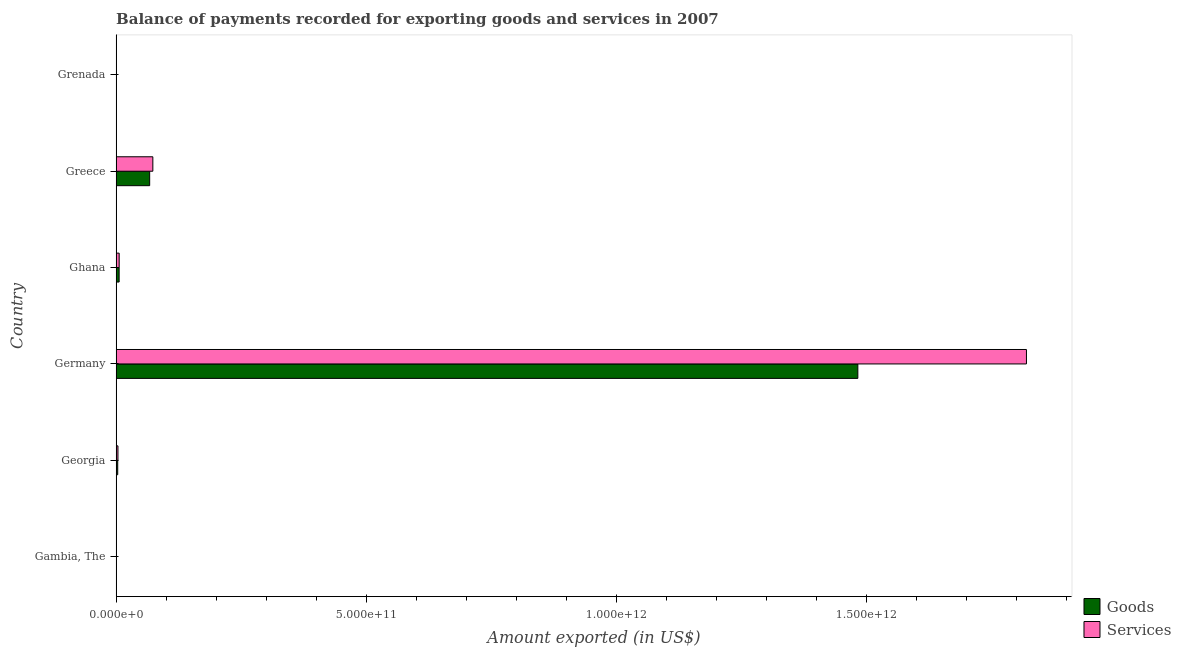How many different coloured bars are there?
Offer a terse response. 2. Are the number of bars per tick equal to the number of legend labels?
Your answer should be compact. Yes. Are the number of bars on each tick of the Y-axis equal?
Offer a very short reply. Yes. What is the label of the 1st group of bars from the top?
Offer a terse response. Grenada. What is the amount of services exported in Georgia?
Your answer should be compact. 3.65e+09. Across all countries, what is the maximum amount of goods exported?
Offer a terse response. 1.48e+12. Across all countries, what is the minimum amount of services exported?
Provide a short and direct response. 2.23e+08. In which country was the amount of goods exported maximum?
Provide a short and direct response. Germany. In which country was the amount of goods exported minimum?
Give a very brief answer. Grenada. What is the total amount of services exported in the graph?
Offer a terse response. 1.90e+12. What is the difference between the amount of goods exported in Gambia, The and that in Ghana?
Offer a very short reply. -5.74e+09. What is the difference between the amount of goods exported in Gambia, The and the amount of services exported in Greece?
Provide a succinct answer. -7.31e+1. What is the average amount of services exported per country?
Offer a terse response. 3.17e+11. What is the difference between the amount of services exported and amount of goods exported in Grenada?
Your answer should be very brief. 1.37e+07. In how many countries, is the amount of goods exported greater than 1100000000000 US$?
Offer a very short reply. 1. What is the ratio of the amount of goods exported in Georgia to that in Greece?
Provide a succinct answer. 0.05. Is the amount of services exported in Gambia, The less than that in Germany?
Your answer should be very brief. Yes. Is the difference between the amount of goods exported in Georgia and Grenada greater than the difference between the amount of services exported in Georgia and Grenada?
Provide a short and direct response. No. What is the difference between the highest and the second highest amount of goods exported?
Make the answer very short. 1.42e+12. What is the difference between the highest and the lowest amount of services exported?
Give a very brief answer. 1.82e+12. What does the 1st bar from the top in Georgia represents?
Your answer should be compact. Services. What does the 1st bar from the bottom in Grenada represents?
Your answer should be very brief. Goods. How many bars are there?
Offer a terse response. 12. How many countries are there in the graph?
Your response must be concise. 6. What is the difference between two consecutive major ticks on the X-axis?
Your answer should be very brief. 5.00e+11. Does the graph contain grids?
Ensure brevity in your answer.  No. Where does the legend appear in the graph?
Your response must be concise. Bottom right. How many legend labels are there?
Your response must be concise. 2. What is the title of the graph?
Your answer should be compact. Balance of payments recorded for exporting goods and services in 2007. What is the label or title of the X-axis?
Your response must be concise. Amount exported (in US$). What is the Amount exported (in US$) in Goods in Gambia, The?
Ensure brevity in your answer.  2.62e+08. What is the Amount exported (in US$) in Services in Gambia, The?
Make the answer very short. 2.71e+08. What is the Amount exported (in US$) in Goods in Georgia?
Ensure brevity in your answer.  3.16e+09. What is the Amount exported (in US$) in Services in Georgia?
Offer a very short reply. 3.65e+09. What is the Amount exported (in US$) of Goods in Germany?
Offer a very short reply. 1.48e+12. What is the Amount exported (in US$) of Services in Germany?
Give a very brief answer. 1.82e+12. What is the Amount exported (in US$) in Goods in Ghana?
Provide a succinct answer. 6.00e+09. What is the Amount exported (in US$) of Services in Ghana?
Your answer should be compact. 6.09e+09. What is the Amount exported (in US$) in Goods in Greece?
Keep it short and to the point. 6.70e+1. What is the Amount exported (in US$) of Services in Greece?
Your answer should be very brief. 7.34e+1. What is the Amount exported (in US$) in Goods in Grenada?
Offer a terse response. 2.10e+08. What is the Amount exported (in US$) in Services in Grenada?
Your answer should be compact. 2.23e+08. Across all countries, what is the maximum Amount exported (in US$) in Goods?
Provide a short and direct response. 1.48e+12. Across all countries, what is the maximum Amount exported (in US$) of Services?
Offer a very short reply. 1.82e+12. Across all countries, what is the minimum Amount exported (in US$) in Goods?
Keep it short and to the point. 2.10e+08. Across all countries, what is the minimum Amount exported (in US$) of Services?
Make the answer very short. 2.23e+08. What is the total Amount exported (in US$) of Goods in the graph?
Your answer should be very brief. 1.56e+12. What is the total Amount exported (in US$) in Services in the graph?
Ensure brevity in your answer.  1.90e+12. What is the difference between the Amount exported (in US$) of Goods in Gambia, The and that in Georgia?
Your answer should be compact. -2.90e+09. What is the difference between the Amount exported (in US$) in Services in Gambia, The and that in Georgia?
Your answer should be very brief. -3.37e+09. What is the difference between the Amount exported (in US$) of Goods in Gambia, The and that in Germany?
Ensure brevity in your answer.  -1.48e+12. What is the difference between the Amount exported (in US$) of Services in Gambia, The and that in Germany?
Provide a short and direct response. -1.82e+12. What is the difference between the Amount exported (in US$) of Goods in Gambia, The and that in Ghana?
Provide a short and direct response. -5.74e+09. What is the difference between the Amount exported (in US$) in Services in Gambia, The and that in Ghana?
Keep it short and to the point. -5.82e+09. What is the difference between the Amount exported (in US$) of Goods in Gambia, The and that in Greece?
Give a very brief answer. -6.68e+1. What is the difference between the Amount exported (in US$) of Services in Gambia, The and that in Greece?
Keep it short and to the point. -7.31e+1. What is the difference between the Amount exported (in US$) of Goods in Gambia, The and that in Grenada?
Provide a short and direct response. 5.27e+07. What is the difference between the Amount exported (in US$) in Services in Gambia, The and that in Grenada?
Keep it short and to the point. 4.81e+07. What is the difference between the Amount exported (in US$) of Goods in Georgia and that in Germany?
Your answer should be very brief. -1.48e+12. What is the difference between the Amount exported (in US$) in Services in Georgia and that in Germany?
Your answer should be compact. -1.82e+12. What is the difference between the Amount exported (in US$) of Goods in Georgia and that in Ghana?
Make the answer very short. -2.84e+09. What is the difference between the Amount exported (in US$) of Services in Georgia and that in Ghana?
Offer a terse response. -2.44e+09. What is the difference between the Amount exported (in US$) in Goods in Georgia and that in Greece?
Make the answer very short. -6.39e+1. What is the difference between the Amount exported (in US$) in Services in Georgia and that in Greece?
Ensure brevity in your answer.  -6.97e+1. What is the difference between the Amount exported (in US$) in Goods in Georgia and that in Grenada?
Provide a short and direct response. 2.95e+09. What is the difference between the Amount exported (in US$) of Services in Georgia and that in Grenada?
Provide a short and direct response. 3.42e+09. What is the difference between the Amount exported (in US$) in Goods in Germany and that in Ghana?
Offer a terse response. 1.48e+12. What is the difference between the Amount exported (in US$) of Services in Germany and that in Ghana?
Keep it short and to the point. 1.81e+12. What is the difference between the Amount exported (in US$) of Goods in Germany and that in Greece?
Keep it short and to the point. 1.42e+12. What is the difference between the Amount exported (in US$) in Services in Germany and that in Greece?
Ensure brevity in your answer.  1.75e+12. What is the difference between the Amount exported (in US$) in Goods in Germany and that in Grenada?
Offer a very short reply. 1.48e+12. What is the difference between the Amount exported (in US$) of Services in Germany and that in Grenada?
Provide a short and direct response. 1.82e+12. What is the difference between the Amount exported (in US$) in Goods in Ghana and that in Greece?
Your response must be concise. -6.10e+1. What is the difference between the Amount exported (in US$) of Services in Ghana and that in Greece?
Your answer should be compact. -6.73e+1. What is the difference between the Amount exported (in US$) of Goods in Ghana and that in Grenada?
Your answer should be very brief. 5.79e+09. What is the difference between the Amount exported (in US$) of Services in Ghana and that in Grenada?
Your response must be concise. 5.86e+09. What is the difference between the Amount exported (in US$) of Goods in Greece and that in Grenada?
Offer a terse response. 6.68e+1. What is the difference between the Amount exported (in US$) of Services in Greece and that in Grenada?
Provide a short and direct response. 7.32e+1. What is the difference between the Amount exported (in US$) in Goods in Gambia, The and the Amount exported (in US$) in Services in Georgia?
Ensure brevity in your answer.  -3.38e+09. What is the difference between the Amount exported (in US$) of Goods in Gambia, The and the Amount exported (in US$) of Services in Germany?
Ensure brevity in your answer.  -1.82e+12. What is the difference between the Amount exported (in US$) of Goods in Gambia, The and the Amount exported (in US$) of Services in Ghana?
Your answer should be compact. -5.83e+09. What is the difference between the Amount exported (in US$) of Goods in Gambia, The and the Amount exported (in US$) of Services in Greece?
Ensure brevity in your answer.  -7.31e+1. What is the difference between the Amount exported (in US$) of Goods in Gambia, The and the Amount exported (in US$) of Services in Grenada?
Keep it short and to the point. 3.91e+07. What is the difference between the Amount exported (in US$) of Goods in Georgia and the Amount exported (in US$) of Services in Germany?
Your answer should be compact. -1.82e+12. What is the difference between the Amount exported (in US$) of Goods in Georgia and the Amount exported (in US$) of Services in Ghana?
Ensure brevity in your answer.  -2.93e+09. What is the difference between the Amount exported (in US$) of Goods in Georgia and the Amount exported (in US$) of Services in Greece?
Keep it short and to the point. -7.02e+1. What is the difference between the Amount exported (in US$) in Goods in Georgia and the Amount exported (in US$) in Services in Grenada?
Your response must be concise. 2.94e+09. What is the difference between the Amount exported (in US$) of Goods in Germany and the Amount exported (in US$) of Services in Ghana?
Ensure brevity in your answer.  1.48e+12. What is the difference between the Amount exported (in US$) in Goods in Germany and the Amount exported (in US$) in Services in Greece?
Your answer should be very brief. 1.41e+12. What is the difference between the Amount exported (in US$) of Goods in Germany and the Amount exported (in US$) of Services in Grenada?
Keep it short and to the point. 1.48e+12. What is the difference between the Amount exported (in US$) of Goods in Ghana and the Amount exported (in US$) of Services in Greece?
Provide a succinct answer. -6.74e+1. What is the difference between the Amount exported (in US$) in Goods in Ghana and the Amount exported (in US$) in Services in Grenada?
Ensure brevity in your answer.  5.78e+09. What is the difference between the Amount exported (in US$) of Goods in Greece and the Amount exported (in US$) of Services in Grenada?
Provide a succinct answer. 6.68e+1. What is the average Amount exported (in US$) in Goods per country?
Provide a short and direct response. 2.60e+11. What is the average Amount exported (in US$) of Services per country?
Ensure brevity in your answer.  3.17e+11. What is the difference between the Amount exported (in US$) in Goods and Amount exported (in US$) in Services in Gambia, The?
Your answer should be compact. -8.99e+06. What is the difference between the Amount exported (in US$) of Goods and Amount exported (in US$) of Services in Georgia?
Your response must be concise. -4.83e+08. What is the difference between the Amount exported (in US$) in Goods and Amount exported (in US$) in Services in Germany?
Your response must be concise. -3.37e+11. What is the difference between the Amount exported (in US$) in Goods and Amount exported (in US$) in Services in Ghana?
Offer a terse response. -8.40e+07. What is the difference between the Amount exported (in US$) of Goods and Amount exported (in US$) of Services in Greece?
Give a very brief answer. -6.34e+09. What is the difference between the Amount exported (in US$) in Goods and Amount exported (in US$) in Services in Grenada?
Your answer should be compact. -1.37e+07. What is the ratio of the Amount exported (in US$) in Goods in Gambia, The to that in Georgia?
Make the answer very short. 0.08. What is the ratio of the Amount exported (in US$) of Services in Gambia, The to that in Georgia?
Make the answer very short. 0.07. What is the ratio of the Amount exported (in US$) of Goods in Gambia, The to that in Germany?
Provide a succinct answer. 0. What is the ratio of the Amount exported (in US$) of Services in Gambia, The to that in Germany?
Offer a terse response. 0. What is the ratio of the Amount exported (in US$) of Goods in Gambia, The to that in Ghana?
Your response must be concise. 0.04. What is the ratio of the Amount exported (in US$) in Services in Gambia, The to that in Ghana?
Give a very brief answer. 0.04. What is the ratio of the Amount exported (in US$) in Goods in Gambia, The to that in Greece?
Provide a succinct answer. 0. What is the ratio of the Amount exported (in US$) in Services in Gambia, The to that in Greece?
Ensure brevity in your answer.  0. What is the ratio of the Amount exported (in US$) of Goods in Gambia, The to that in Grenada?
Offer a terse response. 1.25. What is the ratio of the Amount exported (in US$) in Services in Gambia, The to that in Grenada?
Your response must be concise. 1.22. What is the ratio of the Amount exported (in US$) of Goods in Georgia to that in Germany?
Ensure brevity in your answer.  0. What is the ratio of the Amount exported (in US$) of Services in Georgia to that in Germany?
Your response must be concise. 0. What is the ratio of the Amount exported (in US$) in Goods in Georgia to that in Ghana?
Provide a short and direct response. 0.53. What is the ratio of the Amount exported (in US$) of Services in Georgia to that in Ghana?
Your response must be concise. 0.6. What is the ratio of the Amount exported (in US$) in Goods in Georgia to that in Greece?
Your answer should be very brief. 0.05. What is the ratio of the Amount exported (in US$) of Services in Georgia to that in Greece?
Your answer should be compact. 0.05. What is the ratio of the Amount exported (in US$) in Goods in Georgia to that in Grenada?
Provide a short and direct response. 15.09. What is the ratio of the Amount exported (in US$) of Services in Georgia to that in Grenada?
Make the answer very short. 16.33. What is the ratio of the Amount exported (in US$) of Goods in Germany to that in Ghana?
Your response must be concise. 246.92. What is the ratio of the Amount exported (in US$) of Services in Germany to that in Ghana?
Make the answer very short. 298.88. What is the ratio of the Amount exported (in US$) in Goods in Germany to that in Greece?
Ensure brevity in your answer.  22.11. What is the ratio of the Amount exported (in US$) of Services in Germany to that in Greece?
Your response must be concise. 24.79. What is the ratio of the Amount exported (in US$) in Goods in Germany to that in Grenada?
Your answer should be compact. 7074.97. What is the ratio of the Amount exported (in US$) of Services in Germany to that in Grenada?
Make the answer very short. 8151.99. What is the ratio of the Amount exported (in US$) of Goods in Ghana to that in Greece?
Make the answer very short. 0.09. What is the ratio of the Amount exported (in US$) in Services in Ghana to that in Greece?
Give a very brief answer. 0.08. What is the ratio of the Amount exported (in US$) of Goods in Ghana to that in Grenada?
Offer a very short reply. 28.65. What is the ratio of the Amount exported (in US$) of Services in Ghana to that in Grenada?
Provide a short and direct response. 27.28. What is the ratio of the Amount exported (in US$) in Goods in Greece to that in Grenada?
Give a very brief answer. 319.93. What is the ratio of the Amount exported (in US$) of Services in Greece to that in Grenada?
Offer a very short reply. 328.78. What is the difference between the highest and the second highest Amount exported (in US$) in Goods?
Ensure brevity in your answer.  1.42e+12. What is the difference between the highest and the second highest Amount exported (in US$) in Services?
Provide a succinct answer. 1.75e+12. What is the difference between the highest and the lowest Amount exported (in US$) of Goods?
Your answer should be compact. 1.48e+12. What is the difference between the highest and the lowest Amount exported (in US$) of Services?
Offer a very short reply. 1.82e+12. 